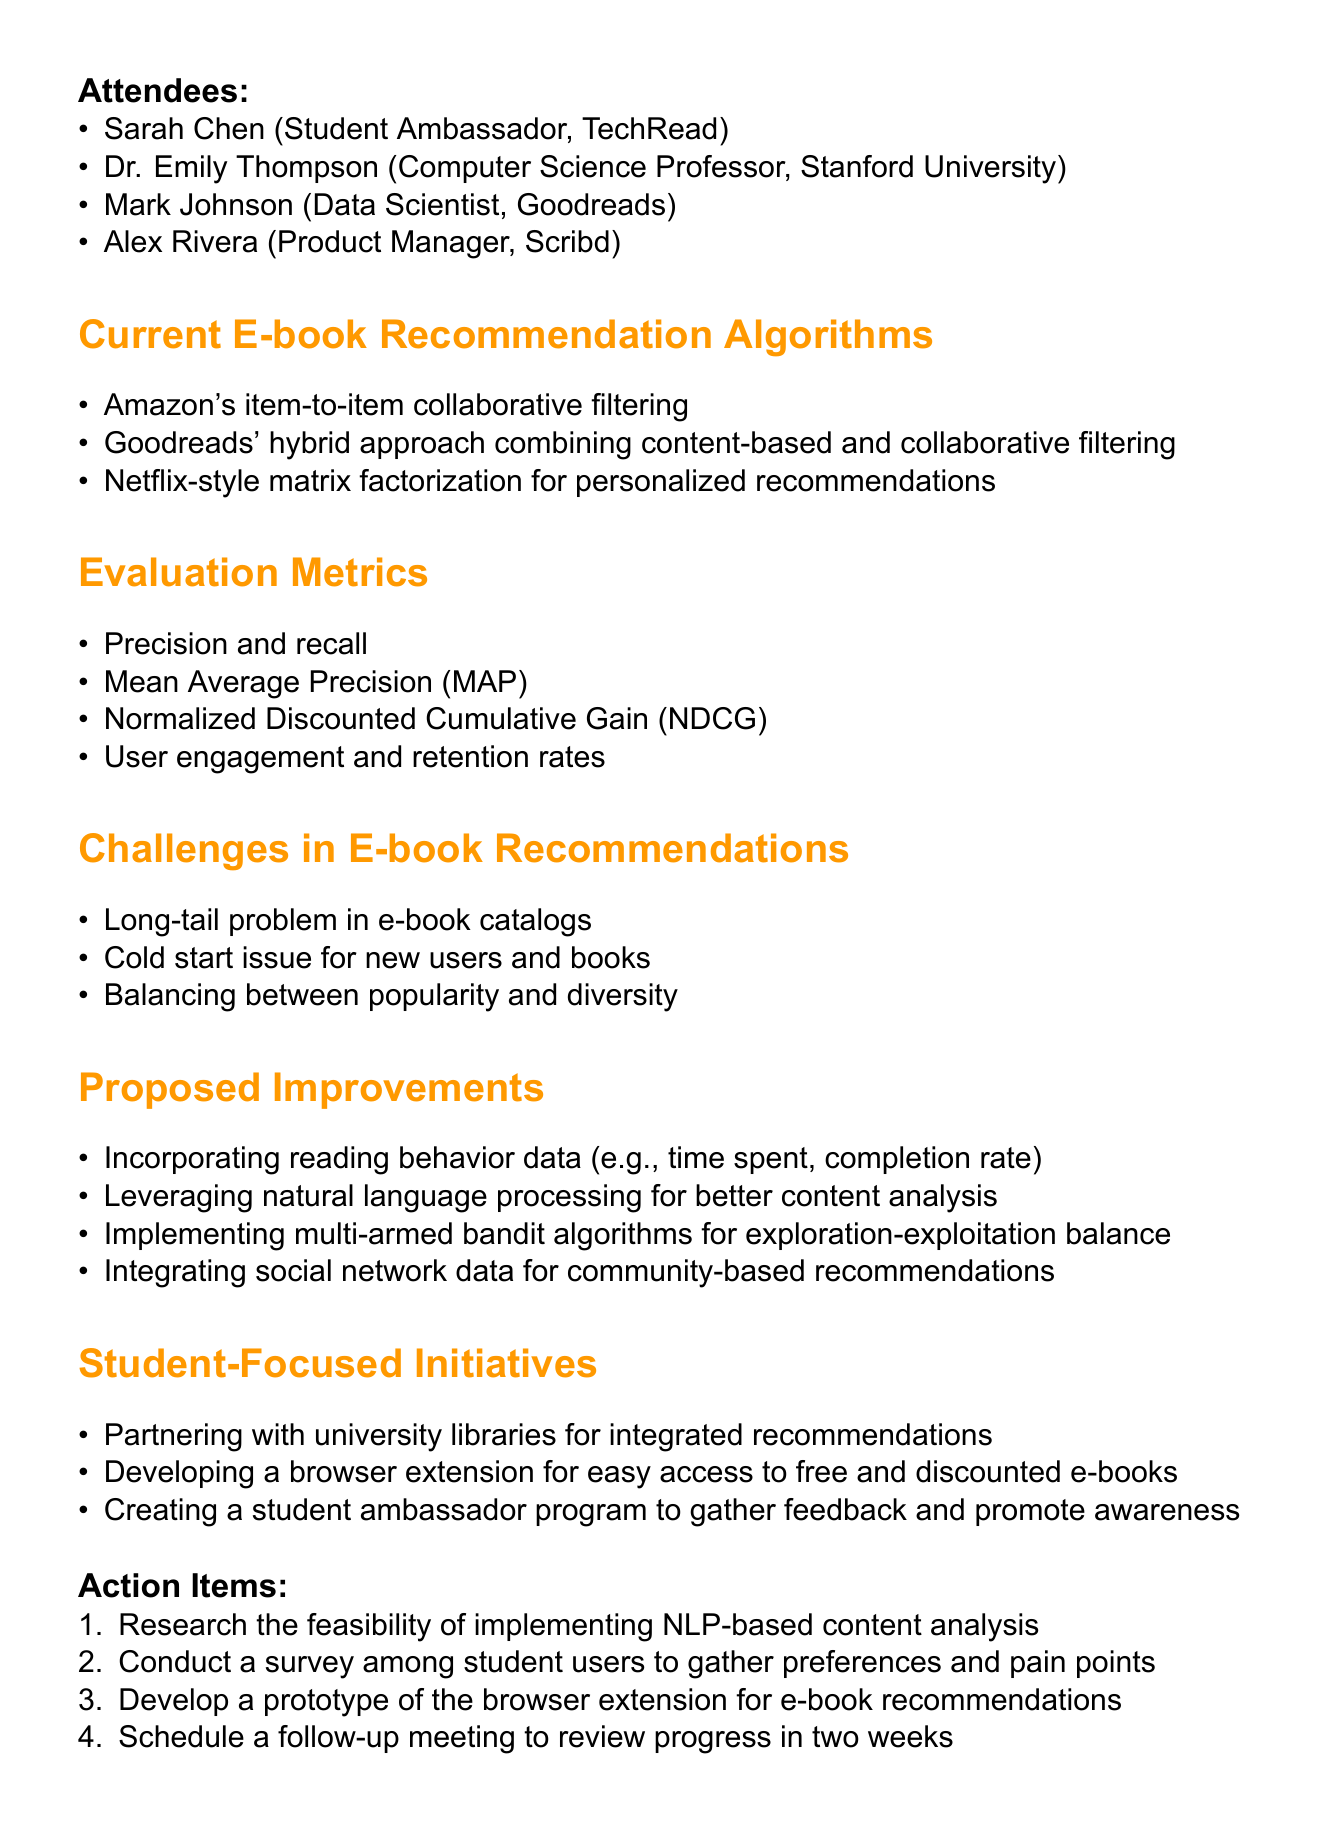What is the title of the meeting? The title of the meeting is provided at the top of the document.
Answer: E-book Recommendation Algorithm Evaluation and Improvement Who is the Data Scientist from Goodreads? The attendees section lists Mark Johnson as the Data Scientist from Goodreads.
Answer: Mark Johnson What metric is used to evaluate user engagement? The evaluation metrics include user engagement among others, highlighting its importance.
Answer: User engagement and retention rates What is one challenge mentioned in e-book recommendations? The document outlines several challenges, including issues faced in e-book recommendations.
Answer: Cold start issue for new users and books What proposed improvement involves user activity data? The proposed improvements section includes points related to reading behavior data.
Answer: Incorporating reading behavior data How many action items are listed? The action items section enumerates a specific number of tasks to be completed.
Answer: Four What is one student-focused initiative? The document highlights initiatives aimed at benefiting students in accessing books.
Answer: Developing a browser extension for easy access to free and discounted e-books What type of algorithm is proposed for the exploration-exploitation balance? Proposed improvements include innovative technical solutions, one of which involves a specific algorithm type.
Answer: Multi-armed bandit algorithms Who is the product manager attending the meeting? The attendees section specifies Alex Rivera's role as the product manager for Scribd.
Answer: Alex Rivera 